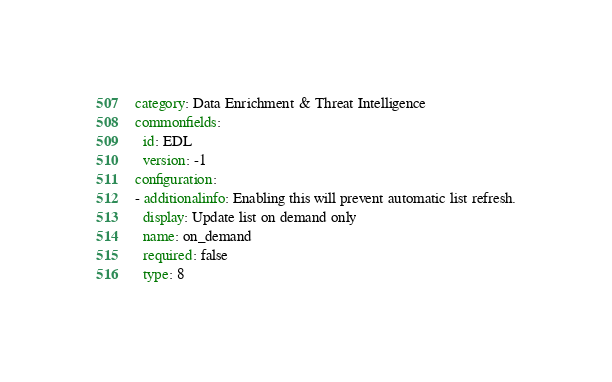Convert code to text. <code><loc_0><loc_0><loc_500><loc_500><_YAML_>category: Data Enrichment & Threat Intelligence
commonfields:
  id: EDL
  version: -1
configuration:
- additionalinfo: Enabling this will prevent automatic list refresh.
  display: Update list on demand only
  name: on_demand
  required: false
  type: 8</code> 